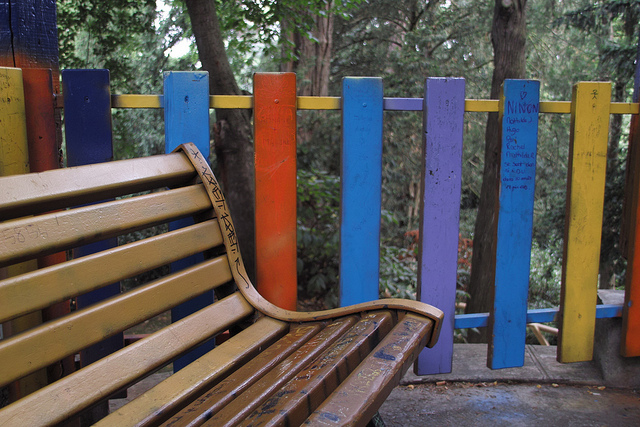Read all the text in this image. NINON 